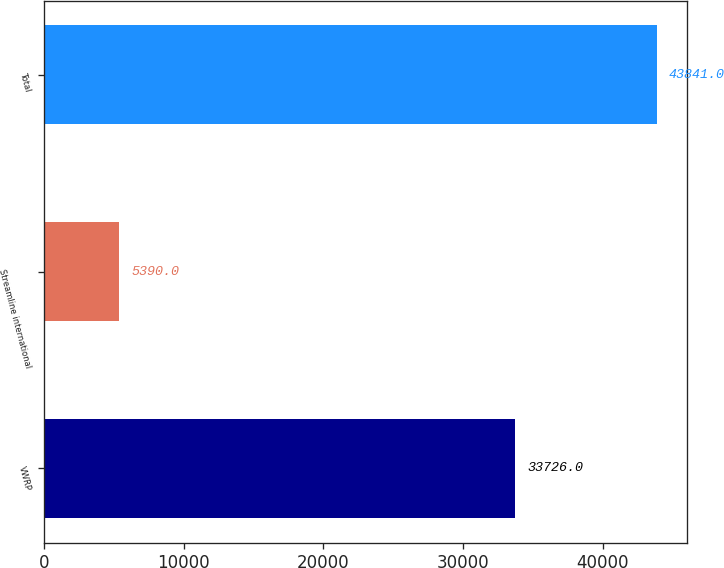<chart> <loc_0><loc_0><loc_500><loc_500><bar_chart><fcel>VWRP<fcel>Streamline international<fcel>Total<nl><fcel>33726<fcel>5390<fcel>43841<nl></chart> 